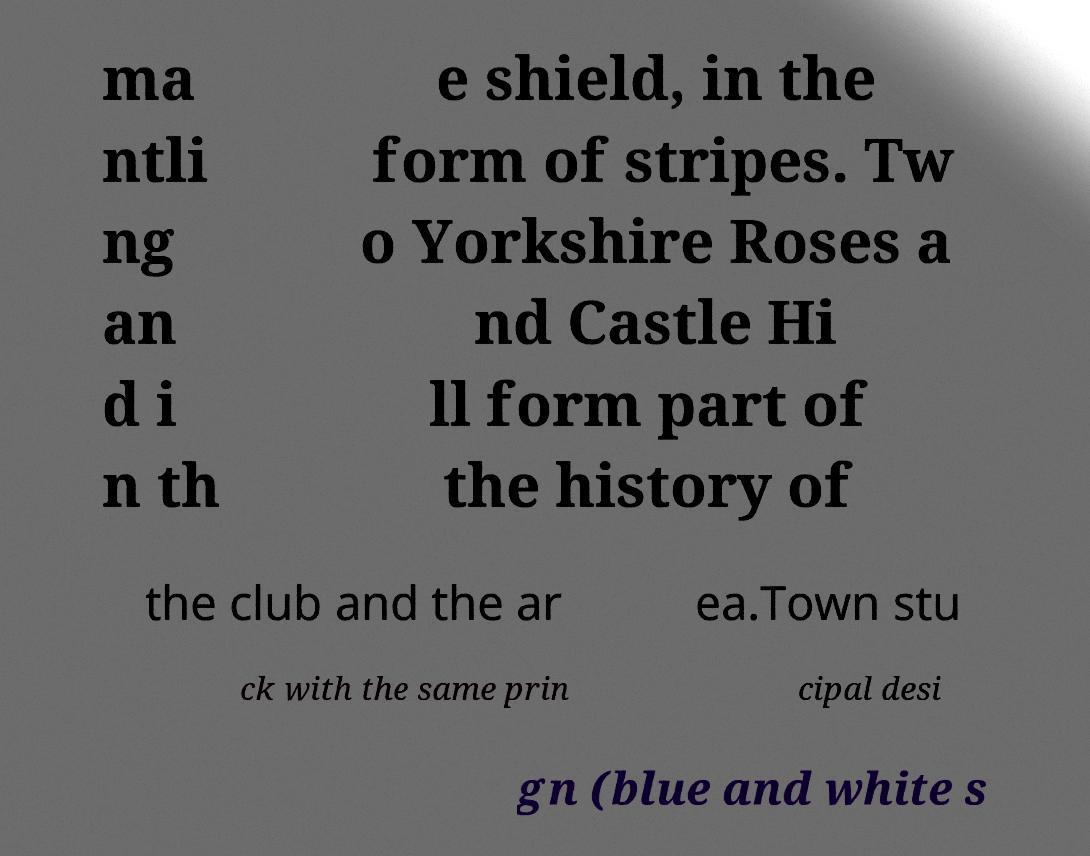Could you assist in decoding the text presented in this image and type it out clearly? ma ntli ng an d i n th e shield, in the form of stripes. Tw o Yorkshire Roses a nd Castle Hi ll form part of the history of the club and the ar ea.Town stu ck with the same prin cipal desi gn (blue and white s 